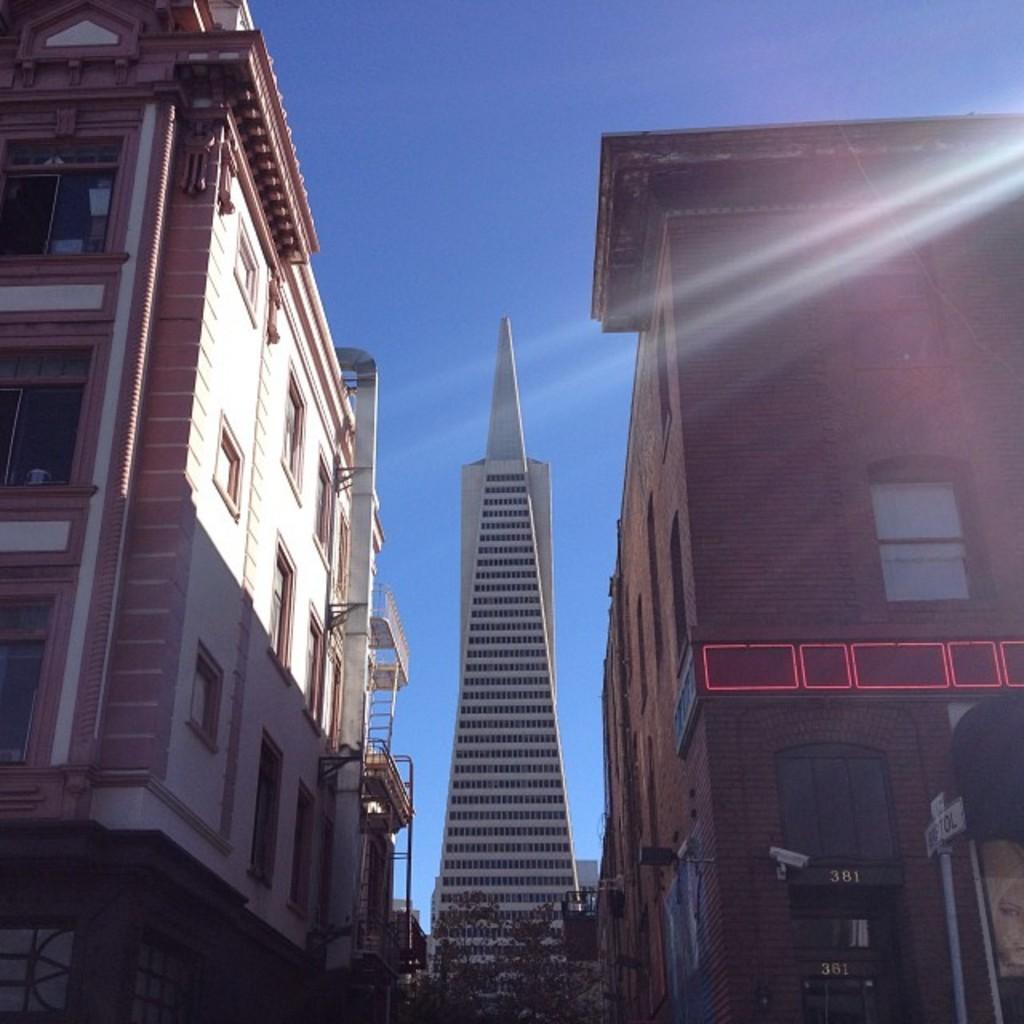How would you summarize this image in a sentence or two? In this image I can see few buildings. At the bottom there are few trees and a pole. At the top of the image I can see the sky. 